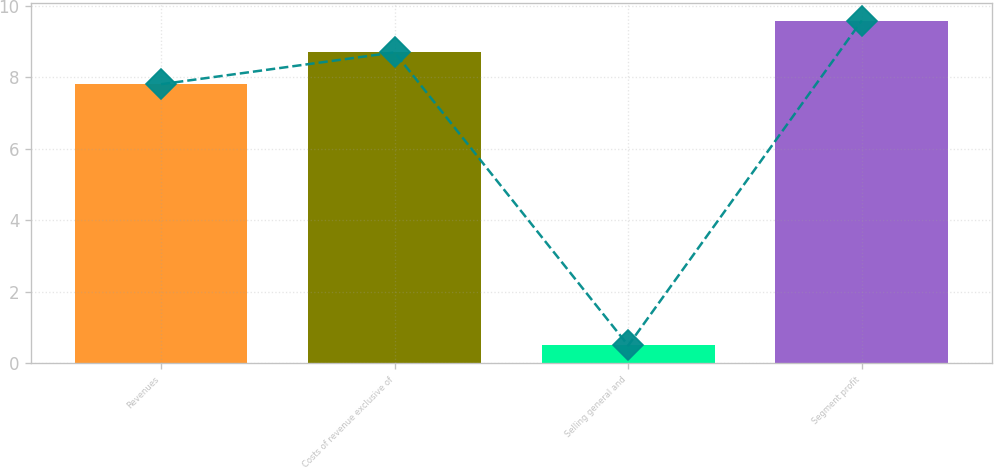Convert chart to OTSL. <chart><loc_0><loc_0><loc_500><loc_500><bar_chart><fcel>Revenues<fcel>Costs of revenue exclusive of<fcel>Selling general and<fcel>Segment profit<nl><fcel>7.8<fcel>8.69<fcel>0.5<fcel>9.58<nl></chart> 